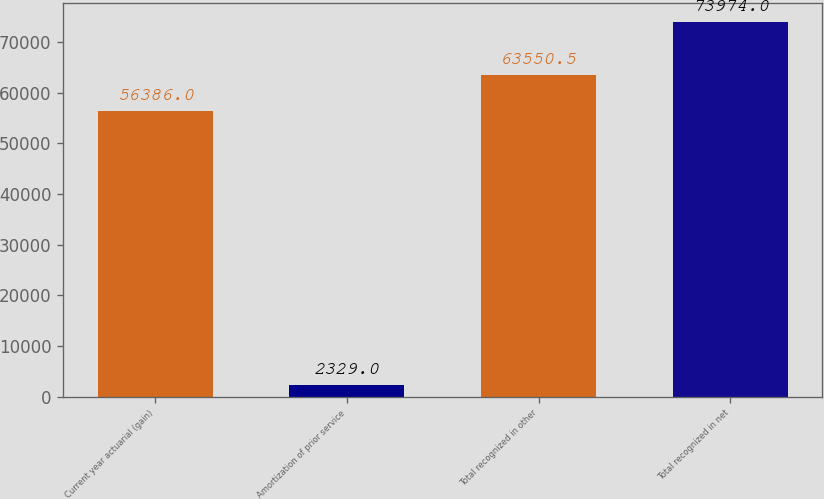<chart> <loc_0><loc_0><loc_500><loc_500><bar_chart><fcel>Current year actuarial (gain)<fcel>Amortization of prior service<fcel>Total recognized in other<fcel>Total recognized in net<nl><fcel>56386<fcel>2329<fcel>63550.5<fcel>73974<nl></chart> 